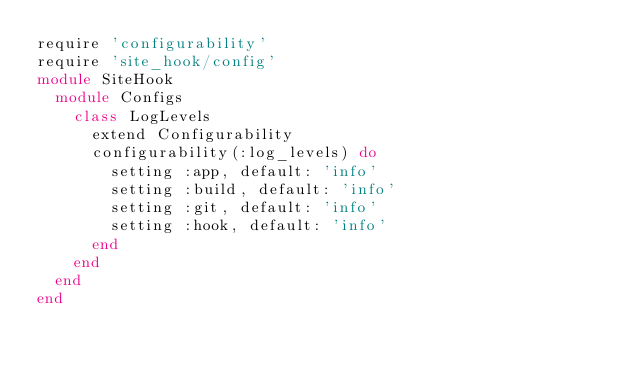Convert code to text. <code><loc_0><loc_0><loc_500><loc_500><_Ruby_>require 'configurability'
require 'site_hook/config'
module SiteHook
  module Configs
    class LogLevels
      extend Configurability
      configurability(:log_levels) do
        setting :app, default: 'info'
        setting :build, default: 'info'
        setting :git, default: 'info'
        setting :hook, default: 'info'
      end
    end
  end
end</code> 